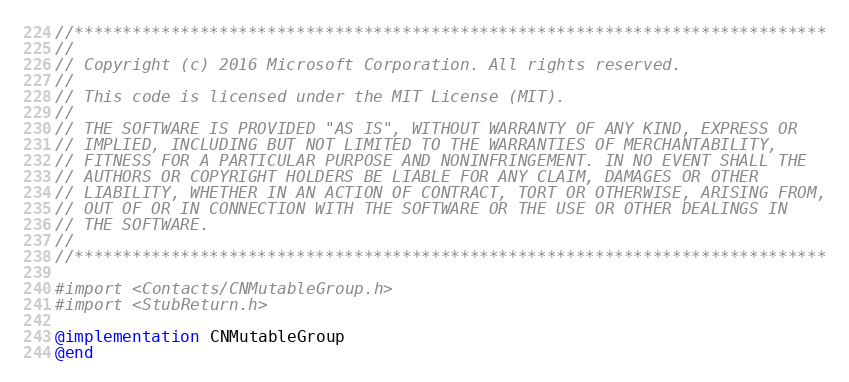Convert code to text. <code><loc_0><loc_0><loc_500><loc_500><_ObjectiveC_>//******************************************************************************
//
// Copyright (c) 2016 Microsoft Corporation. All rights reserved.
//
// This code is licensed under the MIT License (MIT).
//
// THE SOFTWARE IS PROVIDED "AS IS", WITHOUT WARRANTY OF ANY KIND, EXPRESS OR
// IMPLIED, INCLUDING BUT NOT LIMITED TO THE WARRANTIES OF MERCHANTABILITY,
// FITNESS FOR A PARTICULAR PURPOSE AND NONINFRINGEMENT. IN NO EVENT SHALL THE
// AUTHORS OR COPYRIGHT HOLDERS BE LIABLE FOR ANY CLAIM, DAMAGES OR OTHER
// LIABILITY, WHETHER IN AN ACTION OF CONTRACT, TORT OR OTHERWISE, ARISING FROM,
// OUT OF OR IN CONNECTION WITH THE SOFTWARE OR THE USE OR OTHER DEALINGS IN
// THE SOFTWARE.
//
//******************************************************************************

#import <Contacts/CNMutableGroup.h>
#import <StubReturn.h>

@implementation CNMutableGroup
@end
</code> 